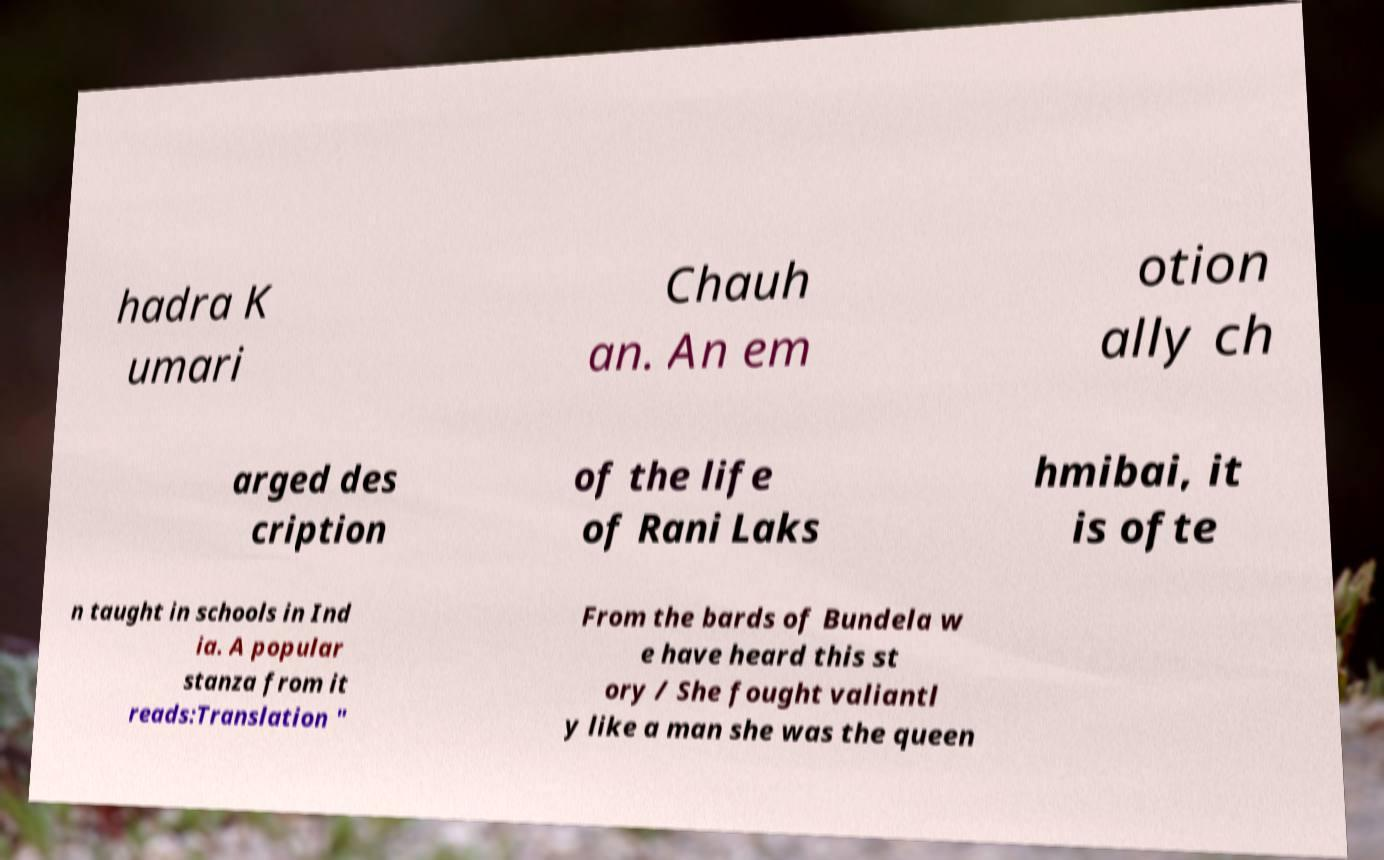Please identify and transcribe the text found in this image. hadra K umari Chauh an. An em otion ally ch arged des cription of the life of Rani Laks hmibai, it is ofte n taught in schools in Ind ia. A popular stanza from it reads:Translation " From the bards of Bundela w e have heard this st ory / She fought valiantl y like a man she was the queen 